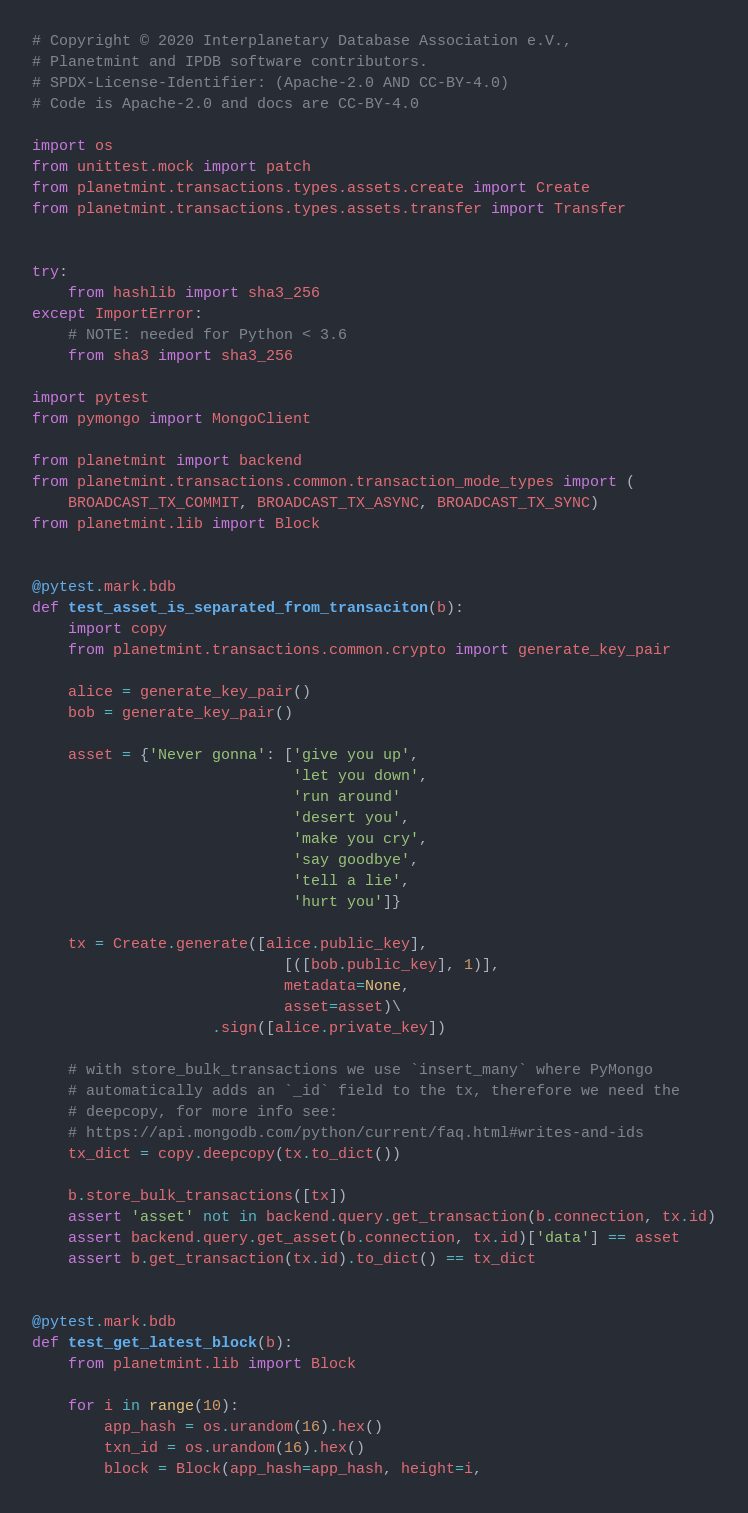Convert code to text. <code><loc_0><loc_0><loc_500><loc_500><_Python_># Copyright © 2020 Interplanetary Database Association e.V.,
# Planetmint and IPDB software contributors.
# SPDX-License-Identifier: (Apache-2.0 AND CC-BY-4.0)
# Code is Apache-2.0 and docs are CC-BY-4.0

import os
from unittest.mock import patch
from planetmint.transactions.types.assets.create import Create
from planetmint.transactions.types.assets.transfer import Transfer


try:
    from hashlib import sha3_256
except ImportError:
    # NOTE: needed for Python < 3.6
    from sha3 import sha3_256

import pytest
from pymongo import MongoClient

from planetmint import backend
from planetmint.transactions.common.transaction_mode_types import (
    BROADCAST_TX_COMMIT, BROADCAST_TX_ASYNC, BROADCAST_TX_SYNC)
from planetmint.lib import Block


@pytest.mark.bdb
def test_asset_is_separated_from_transaciton(b):
    import copy
    from planetmint.transactions.common.crypto import generate_key_pair

    alice = generate_key_pair()
    bob = generate_key_pair()

    asset = {'Never gonna': ['give you up',
                             'let you down',
                             'run around'
                             'desert you',
                             'make you cry',
                             'say goodbye',
                             'tell a lie',
                             'hurt you']}

    tx = Create.generate([alice.public_key],
                            [([bob.public_key], 1)],
                            metadata=None,
                            asset=asset)\
                    .sign([alice.private_key])

    # with store_bulk_transactions we use `insert_many` where PyMongo
    # automatically adds an `_id` field to the tx, therefore we need the
    # deepcopy, for more info see:
    # https://api.mongodb.com/python/current/faq.html#writes-and-ids
    tx_dict = copy.deepcopy(tx.to_dict())

    b.store_bulk_transactions([tx])
    assert 'asset' not in backend.query.get_transaction(b.connection, tx.id)
    assert backend.query.get_asset(b.connection, tx.id)['data'] == asset
    assert b.get_transaction(tx.id).to_dict() == tx_dict


@pytest.mark.bdb
def test_get_latest_block(b):
    from planetmint.lib import Block

    for i in range(10):
        app_hash = os.urandom(16).hex()
        txn_id = os.urandom(16).hex()
        block = Block(app_hash=app_hash, height=i,</code> 